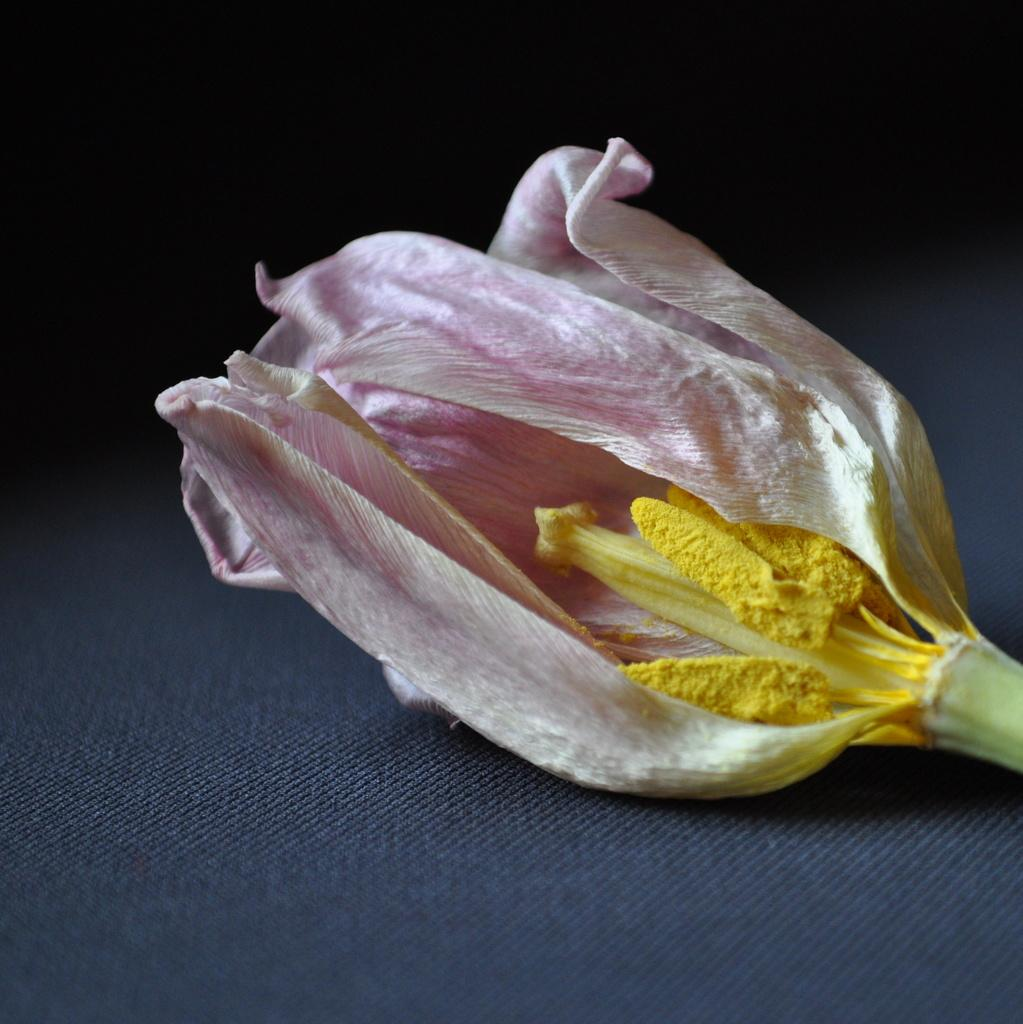What type of flower is in the image? There is a dry pink flower in the image. What is the color of the flower's stigma? The flower has a yellow stigma. On what surface is the flower placed? The flower is placed on a cloth. What type of wax is being used by the mother in the image? There is no mother or wax present in the image; it features a dry pink flower placed on a cloth. 